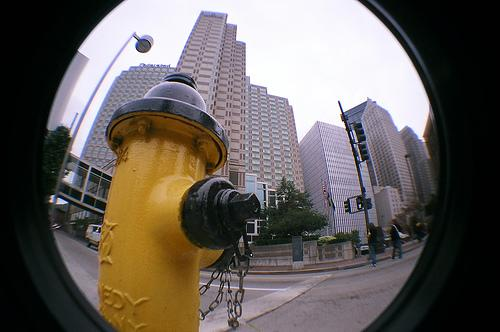Explain the presence of a particular object or element that adds to the image's composition. The yellow and black fire hydrant is an eye-catching element that adds contrast to the urban scene. How many people can be seen walking on the street? Two groups of people are walking on the street. What color is the fire hydrant, and is there anything particular about its design? The fire hydrant is yellow and black, with a chain hanging from it. List three primary items found in the image. Fire hydrant, traffic light pole, tall city buildings. Identify an interesting architectural feature in the image. There's a walkway connecting two buildings over the city street. Describe the interaction between the fire hydrant and the surrounding environment. The yellow and black fire hydrant stands out against the grey street and tall buildings, with the chain hanging from it hinting at a possible function in the cityscape. Provide a sentiment analysis of the image - is it positive, negative, or neutral? The image is neutral, as it shows a normal city scene without any strong emotions or events. Estimate the number of buildings depicted in the image. Several buildings are depicted, with at least six clearly visible. What is the general weather condition in the image based on the sky? The sky is cloudy and white, suggesting overcast weather. Briefly describe the scene taking place in the street. People are walking on the street, some are crossing, and a vehicle is seen on the road. Observe the flock of birds flying across the cloudy sky above the city. There are no birds mentioned in the list of objects, so asking someone to observe them would cause confusion. Notice the big red bus parked on the side of the street next to the tall buildings. No, it's not mentioned in the image. Marvel at the beautiful flowerbed next to the street where people are walking. There is no mention of a flowerbed in the list of objects in the image, so asking someone to marvel at it would be misleading and confusing. 